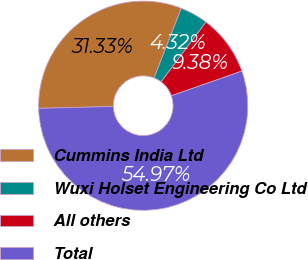Convert chart. <chart><loc_0><loc_0><loc_500><loc_500><pie_chart><fcel>Cummins India Ltd<fcel>Wuxi Holset Engineering Co Ltd<fcel>All others<fcel>Total<nl><fcel>31.33%<fcel>4.32%<fcel>9.38%<fcel>54.97%<nl></chart> 